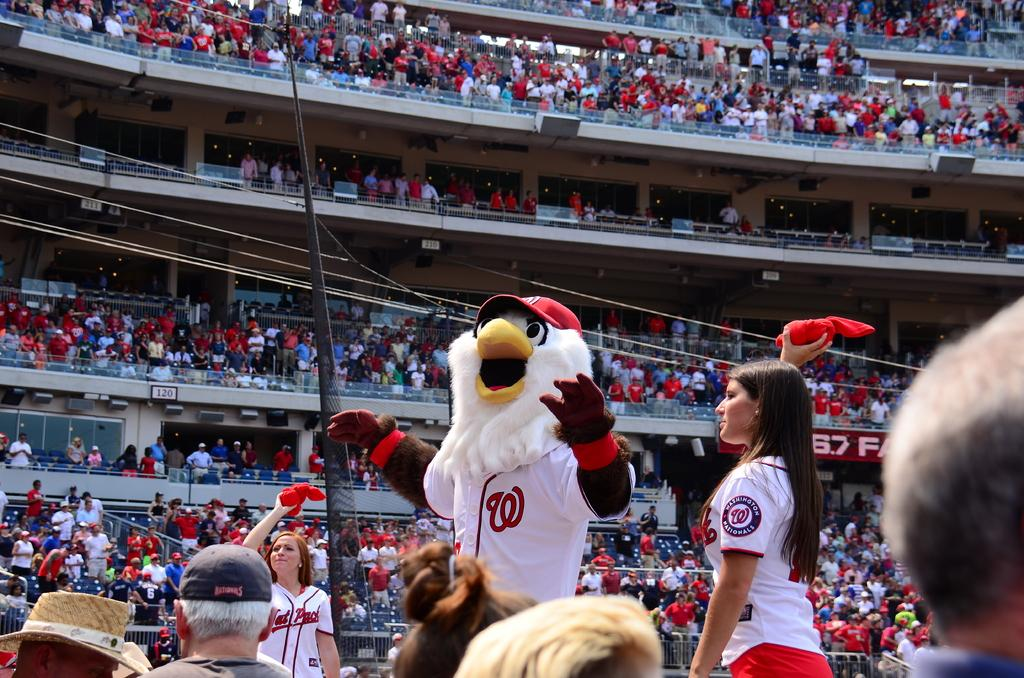<image>
Write a terse but informative summary of the picture. A mascot with a W on his shirt entertains the crowd. 